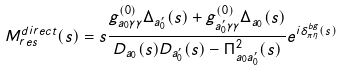Convert formula to latex. <formula><loc_0><loc_0><loc_500><loc_500>M ^ { d i r e c t } _ { r e s } ( s ) = s \frac { g ^ { ( 0 ) } _ { a _ { 0 } \gamma \gamma } \Delta _ { a ^ { \prime } _ { 0 } } ( s ) + g ^ { ( 0 ) } _ { a ^ { \prime } _ { 0 } \gamma \gamma } \Delta _ { a _ { 0 } } ( s ) } { D _ { a _ { 0 } } ( s ) D _ { a ^ { \prime } _ { 0 } } ( s ) - \Pi ^ { 2 } _ { a _ { 0 } a ^ { \prime } _ { 0 } } ( s ) } e ^ { i \delta _ { \pi \eta } ^ { b g } ( s ) }</formula> 